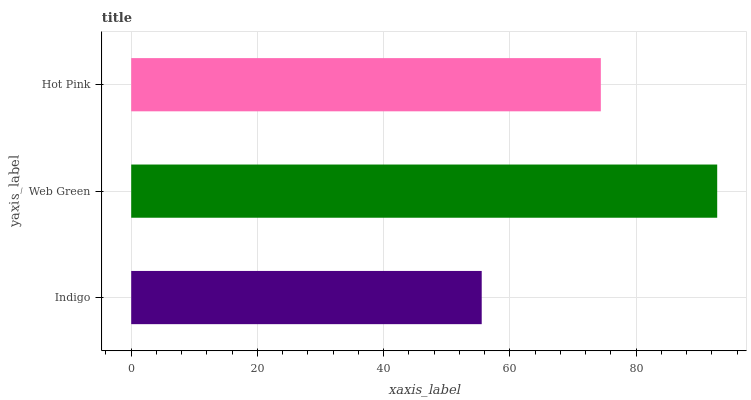Is Indigo the minimum?
Answer yes or no. Yes. Is Web Green the maximum?
Answer yes or no. Yes. Is Hot Pink the minimum?
Answer yes or no. No. Is Hot Pink the maximum?
Answer yes or no. No. Is Web Green greater than Hot Pink?
Answer yes or no. Yes. Is Hot Pink less than Web Green?
Answer yes or no. Yes. Is Hot Pink greater than Web Green?
Answer yes or no. No. Is Web Green less than Hot Pink?
Answer yes or no. No. Is Hot Pink the high median?
Answer yes or no. Yes. Is Hot Pink the low median?
Answer yes or no. Yes. Is Indigo the high median?
Answer yes or no. No. Is Indigo the low median?
Answer yes or no. No. 